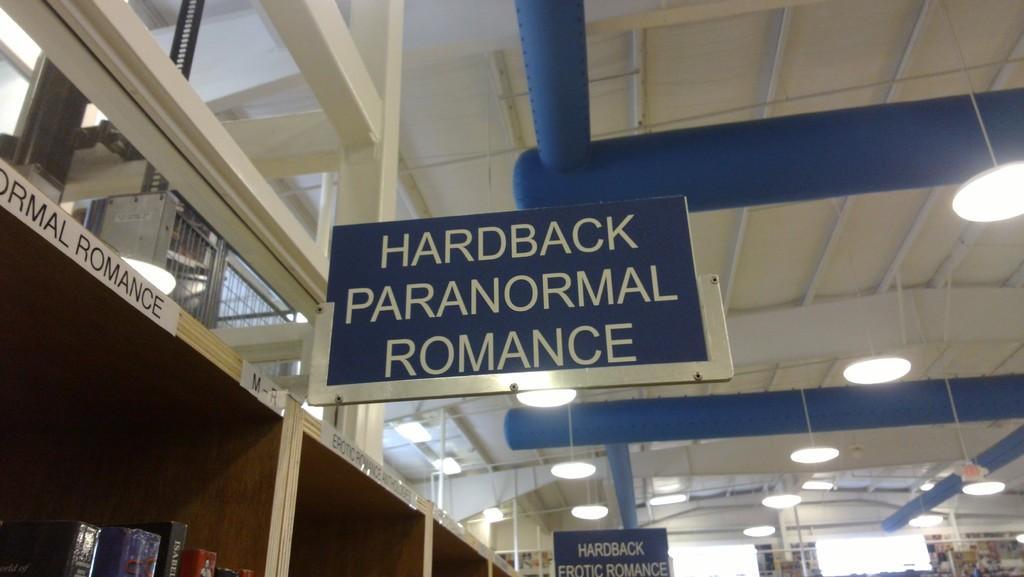Could you give a brief overview of what you see in this image? In this image we can see some name boards, lights and other objects. At the bottom of the image there are some books in the shelf. At the top of the image there is the ceiling with some rods. 